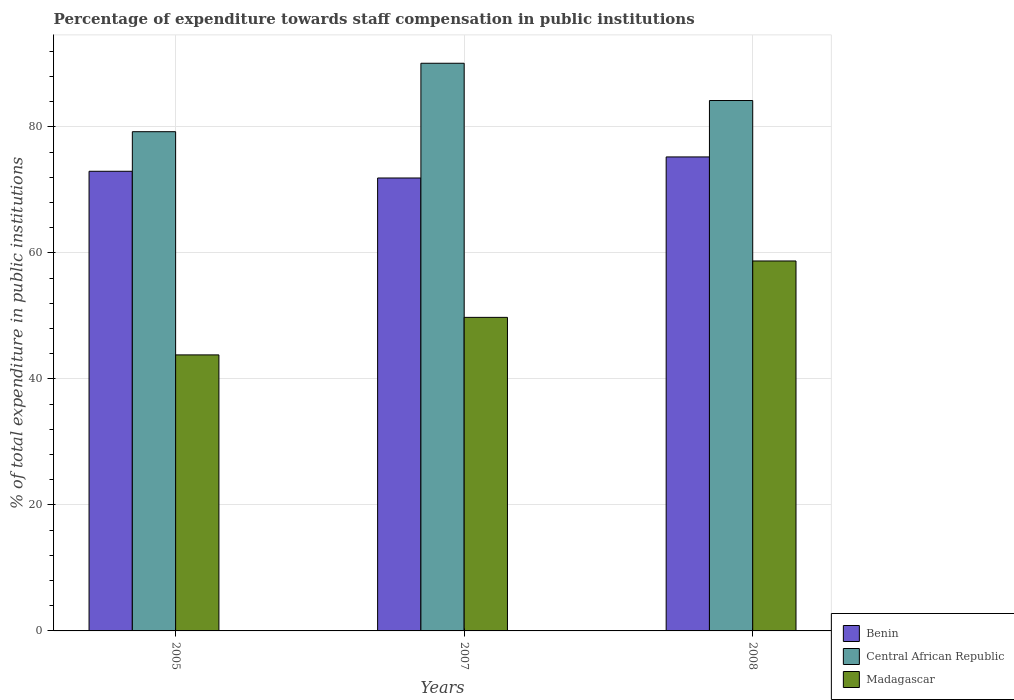How many different coloured bars are there?
Keep it short and to the point. 3. How many groups of bars are there?
Keep it short and to the point. 3. Are the number of bars on each tick of the X-axis equal?
Provide a succinct answer. Yes. How many bars are there on the 2nd tick from the left?
Give a very brief answer. 3. What is the label of the 1st group of bars from the left?
Your response must be concise. 2005. In how many cases, is the number of bars for a given year not equal to the number of legend labels?
Provide a short and direct response. 0. What is the percentage of expenditure towards staff compensation in Madagascar in 2007?
Your response must be concise. 49.77. Across all years, what is the maximum percentage of expenditure towards staff compensation in Benin?
Offer a terse response. 75.24. Across all years, what is the minimum percentage of expenditure towards staff compensation in Benin?
Give a very brief answer. 71.89. In which year was the percentage of expenditure towards staff compensation in Madagascar maximum?
Offer a terse response. 2008. What is the total percentage of expenditure towards staff compensation in Central African Republic in the graph?
Provide a short and direct response. 253.54. What is the difference between the percentage of expenditure towards staff compensation in Madagascar in 2005 and that in 2007?
Offer a terse response. -5.96. What is the difference between the percentage of expenditure towards staff compensation in Benin in 2007 and the percentage of expenditure towards staff compensation in Madagascar in 2005?
Give a very brief answer. 28.08. What is the average percentage of expenditure towards staff compensation in Madagascar per year?
Your response must be concise. 50.77. In the year 2007, what is the difference between the percentage of expenditure towards staff compensation in Central African Republic and percentage of expenditure towards staff compensation in Madagascar?
Provide a short and direct response. 40.33. What is the ratio of the percentage of expenditure towards staff compensation in Benin in 2005 to that in 2008?
Your answer should be compact. 0.97. What is the difference between the highest and the second highest percentage of expenditure towards staff compensation in Central African Republic?
Your answer should be compact. 5.92. What is the difference between the highest and the lowest percentage of expenditure towards staff compensation in Central African Republic?
Provide a succinct answer. 10.86. What does the 1st bar from the left in 2005 represents?
Provide a succinct answer. Benin. What does the 2nd bar from the right in 2007 represents?
Make the answer very short. Central African Republic. How many bars are there?
Offer a terse response. 9. Are all the bars in the graph horizontal?
Provide a succinct answer. No. How many years are there in the graph?
Ensure brevity in your answer.  3. What is the difference between two consecutive major ticks on the Y-axis?
Ensure brevity in your answer.  20. How many legend labels are there?
Keep it short and to the point. 3. How are the legend labels stacked?
Give a very brief answer. Vertical. What is the title of the graph?
Your answer should be compact. Percentage of expenditure towards staff compensation in public institutions. Does "Madagascar" appear as one of the legend labels in the graph?
Give a very brief answer. Yes. What is the label or title of the X-axis?
Provide a succinct answer. Years. What is the label or title of the Y-axis?
Give a very brief answer. % of total expenditure in public institutions. What is the % of total expenditure in public institutions in Benin in 2005?
Provide a short and direct response. 72.96. What is the % of total expenditure in public institutions in Central African Republic in 2005?
Keep it short and to the point. 79.24. What is the % of total expenditure in public institutions in Madagascar in 2005?
Give a very brief answer. 43.81. What is the % of total expenditure in public institutions in Benin in 2007?
Give a very brief answer. 71.89. What is the % of total expenditure in public institutions in Central African Republic in 2007?
Keep it short and to the point. 90.11. What is the % of total expenditure in public institutions of Madagascar in 2007?
Provide a short and direct response. 49.77. What is the % of total expenditure in public institutions in Benin in 2008?
Make the answer very short. 75.24. What is the % of total expenditure in public institutions in Central African Republic in 2008?
Keep it short and to the point. 84.19. What is the % of total expenditure in public institutions in Madagascar in 2008?
Your answer should be very brief. 58.72. Across all years, what is the maximum % of total expenditure in public institutions of Benin?
Give a very brief answer. 75.24. Across all years, what is the maximum % of total expenditure in public institutions in Central African Republic?
Offer a very short reply. 90.11. Across all years, what is the maximum % of total expenditure in public institutions of Madagascar?
Provide a succinct answer. 58.72. Across all years, what is the minimum % of total expenditure in public institutions of Benin?
Provide a short and direct response. 71.89. Across all years, what is the minimum % of total expenditure in public institutions in Central African Republic?
Make the answer very short. 79.24. Across all years, what is the minimum % of total expenditure in public institutions in Madagascar?
Offer a terse response. 43.81. What is the total % of total expenditure in public institutions in Benin in the graph?
Offer a very short reply. 220.09. What is the total % of total expenditure in public institutions in Central African Republic in the graph?
Your answer should be compact. 253.54. What is the total % of total expenditure in public institutions of Madagascar in the graph?
Provide a short and direct response. 152.31. What is the difference between the % of total expenditure in public institutions in Benin in 2005 and that in 2007?
Provide a succinct answer. 1.07. What is the difference between the % of total expenditure in public institutions in Central African Republic in 2005 and that in 2007?
Keep it short and to the point. -10.86. What is the difference between the % of total expenditure in public institutions of Madagascar in 2005 and that in 2007?
Ensure brevity in your answer.  -5.96. What is the difference between the % of total expenditure in public institutions in Benin in 2005 and that in 2008?
Make the answer very short. -2.28. What is the difference between the % of total expenditure in public institutions in Central African Republic in 2005 and that in 2008?
Offer a terse response. -4.95. What is the difference between the % of total expenditure in public institutions in Madagascar in 2005 and that in 2008?
Provide a short and direct response. -14.91. What is the difference between the % of total expenditure in public institutions of Benin in 2007 and that in 2008?
Your answer should be compact. -3.34. What is the difference between the % of total expenditure in public institutions of Central African Republic in 2007 and that in 2008?
Keep it short and to the point. 5.92. What is the difference between the % of total expenditure in public institutions in Madagascar in 2007 and that in 2008?
Offer a terse response. -8.95. What is the difference between the % of total expenditure in public institutions in Benin in 2005 and the % of total expenditure in public institutions in Central African Republic in 2007?
Make the answer very short. -17.15. What is the difference between the % of total expenditure in public institutions of Benin in 2005 and the % of total expenditure in public institutions of Madagascar in 2007?
Make the answer very short. 23.19. What is the difference between the % of total expenditure in public institutions in Central African Republic in 2005 and the % of total expenditure in public institutions in Madagascar in 2007?
Give a very brief answer. 29.47. What is the difference between the % of total expenditure in public institutions in Benin in 2005 and the % of total expenditure in public institutions in Central African Republic in 2008?
Your response must be concise. -11.23. What is the difference between the % of total expenditure in public institutions in Benin in 2005 and the % of total expenditure in public institutions in Madagascar in 2008?
Offer a very short reply. 14.24. What is the difference between the % of total expenditure in public institutions in Central African Republic in 2005 and the % of total expenditure in public institutions in Madagascar in 2008?
Ensure brevity in your answer.  20.52. What is the difference between the % of total expenditure in public institutions of Benin in 2007 and the % of total expenditure in public institutions of Central African Republic in 2008?
Your answer should be very brief. -12.3. What is the difference between the % of total expenditure in public institutions of Benin in 2007 and the % of total expenditure in public institutions of Madagascar in 2008?
Your response must be concise. 13.17. What is the difference between the % of total expenditure in public institutions in Central African Republic in 2007 and the % of total expenditure in public institutions in Madagascar in 2008?
Give a very brief answer. 31.38. What is the average % of total expenditure in public institutions in Benin per year?
Offer a terse response. 73.36. What is the average % of total expenditure in public institutions in Central African Republic per year?
Your response must be concise. 84.51. What is the average % of total expenditure in public institutions in Madagascar per year?
Offer a terse response. 50.77. In the year 2005, what is the difference between the % of total expenditure in public institutions in Benin and % of total expenditure in public institutions in Central African Republic?
Keep it short and to the point. -6.28. In the year 2005, what is the difference between the % of total expenditure in public institutions in Benin and % of total expenditure in public institutions in Madagascar?
Give a very brief answer. 29.15. In the year 2005, what is the difference between the % of total expenditure in public institutions of Central African Republic and % of total expenditure in public institutions of Madagascar?
Give a very brief answer. 35.43. In the year 2007, what is the difference between the % of total expenditure in public institutions in Benin and % of total expenditure in public institutions in Central African Republic?
Provide a short and direct response. -18.21. In the year 2007, what is the difference between the % of total expenditure in public institutions of Benin and % of total expenditure in public institutions of Madagascar?
Offer a very short reply. 22.12. In the year 2007, what is the difference between the % of total expenditure in public institutions in Central African Republic and % of total expenditure in public institutions in Madagascar?
Offer a terse response. 40.33. In the year 2008, what is the difference between the % of total expenditure in public institutions of Benin and % of total expenditure in public institutions of Central African Republic?
Your response must be concise. -8.95. In the year 2008, what is the difference between the % of total expenditure in public institutions in Benin and % of total expenditure in public institutions in Madagascar?
Your answer should be very brief. 16.51. In the year 2008, what is the difference between the % of total expenditure in public institutions in Central African Republic and % of total expenditure in public institutions in Madagascar?
Your answer should be very brief. 25.47. What is the ratio of the % of total expenditure in public institutions in Benin in 2005 to that in 2007?
Your answer should be very brief. 1.01. What is the ratio of the % of total expenditure in public institutions of Central African Republic in 2005 to that in 2007?
Give a very brief answer. 0.88. What is the ratio of the % of total expenditure in public institutions in Madagascar in 2005 to that in 2007?
Keep it short and to the point. 0.88. What is the ratio of the % of total expenditure in public institutions of Benin in 2005 to that in 2008?
Keep it short and to the point. 0.97. What is the ratio of the % of total expenditure in public institutions of Central African Republic in 2005 to that in 2008?
Offer a terse response. 0.94. What is the ratio of the % of total expenditure in public institutions of Madagascar in 2005 to that in 2008?
Your answer should be compact. 0.75. What is the ratio of the % of total expenditure in public institutions of Benin in 2007 to that in 2008?
Your answer should be very brief. 0.96. What is the ratio of the % of total expenditure in public institutions in Central African Republic in 2007 to that in 2008?
Your answer should be very brief. 1.07. What is the ratio of the % of total expenditure in public institutions in Madagascar in 2007 to that in 2008?
Offer a very short reply. 0.85. What is the difference between the highest and the second highest % of total expenditure in public institutions in Benin?
Offer a very short reply. 2.28. What is the difference between the highest and the second highest % of total expenditure in public institutions of Central African Republic?
Give a very brief answer. 5.92. What is the difference between the highest and the second highest % of total expenditure in public institutions in Madagascar?
Your answer should be very brief. 8.95. What is the difference between the highest and the lowest % of total expenditure in public institutions of Benin?
Offer a terse response. 3.34. What is the difference between the highest and the lowest % of total expenditure in public institutions in Central African Republic?
Give a very brief answer. 10.86. What is the difference between the highest and the lowest % of total expenditure in public institutions of Madagascar?
Your answer should be compact. 14.91. 